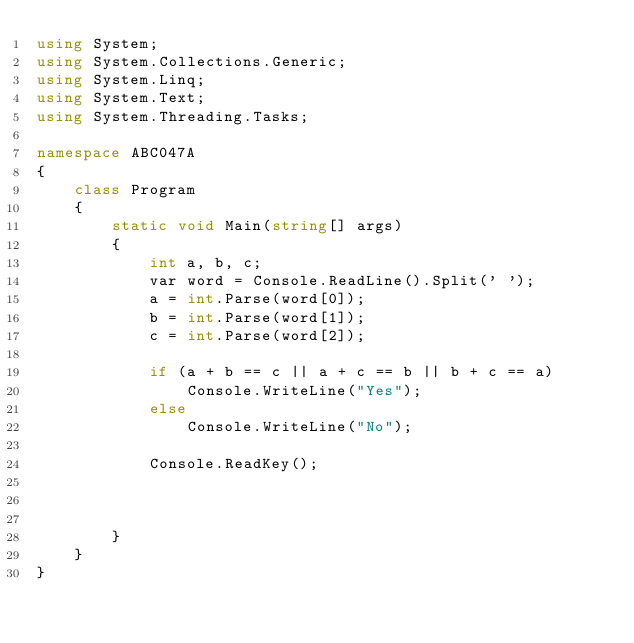<code> <loc_0><loc_0><loc_500><loc_500><_C#_>using System;
using System.Collections.Generic;
using System.Linq;
using System.Text;
using System.Threading.Tasks;

namespace ABC047A
{
    class Program
    {
        static void Main(string[] args)
        {
            int a, b, c;
            var word = Console.ReadLine().Split(' ');
            a = int.Parse(word[0]);
            b = int.Parse(word[1]);
            c = int.Parse(word[2]);

            if (a + b == c || a + c == b || b + c == a)
                Console.WriteLine("Yes");
            else
                Console.WriteLine("No");

            Console.ReadKey();



        }
    }
}
</code> 